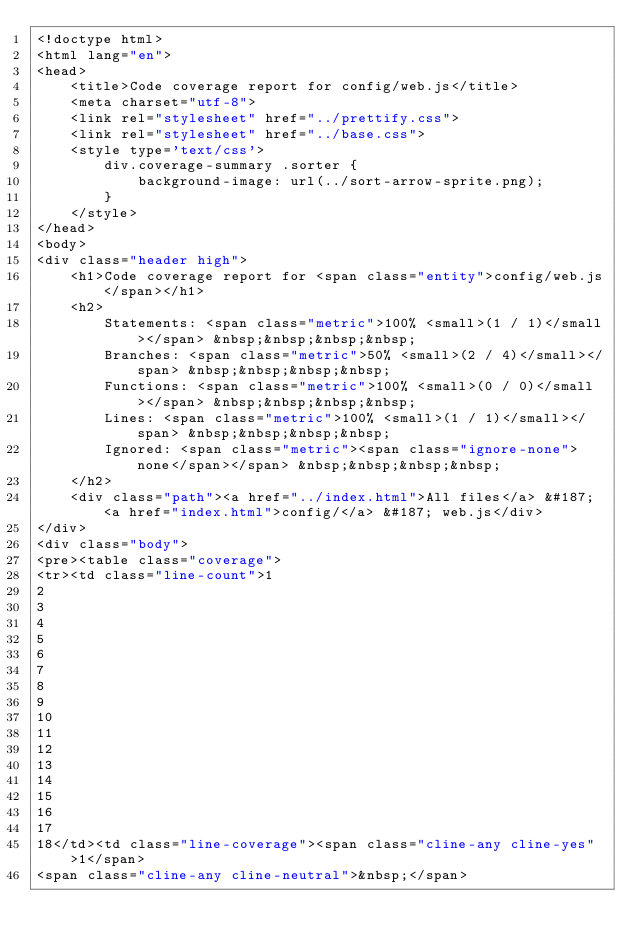<code> <loc_0><loc_0><loc_500><loc_500><_HTML_><!doctype html>
<html lang="en">
<head>
    <title>Code coverage report for config/web.js</title>
    <meta charset="utf-8">
    <link rel="stylesheet" href="../prettify.css">
    <link rel="stylesheet" href="../base.css">
    <style type='text/css'>
        div.coverage-summary .sorter {
            background-image: url(../sort-arrow-sprite.png);
        }
    </style>
</head>
<body>
<div class="header high">
    <h1>Code coverage report for <span class="entity">config/web.js</span></h1>
    <h2>
        Statements: <span class="metric">100% <small>(1 / 1)</small></span> &nbsp;&nbsp;&nbsp;&nbsp;
        Branches: <span class="metric">50% <small>(2 / 4)</small></span> &nbsp;&nbsp;&nbsp;&nbsp;
        Functions: <span class="metric">100% <small>(0 / 0)</small></span> &nbsp;&nbsp;&nbsp;&nbsp;
        Lines: <span class="metric">100% <small>(1 / 1)</small></span> &nbsp;&nbsp;&nbsp;&nbsp;
        Ignored: <span class="metric"><span class="ignore-none">none</span></span> &nbsp;&nbsp;&nbsp;&nbsp;
    </h2>
    <div class="path"><a href="../index.html">All files</a> &#187; <a href="index.html">config/</a> &#187; web.js</div>
</div>
<div class="body">
<pre><table class="coverage">
<tr><td class="line-count">1
2
3
4
5
6
7
8
9
10
11
12
13
14
15
16
17
18</td><td class="line-coverage"><span class="cline-any cline-yes">1</span>
<span class="cline-any cline-neutral">&nbsp;</span></code> 